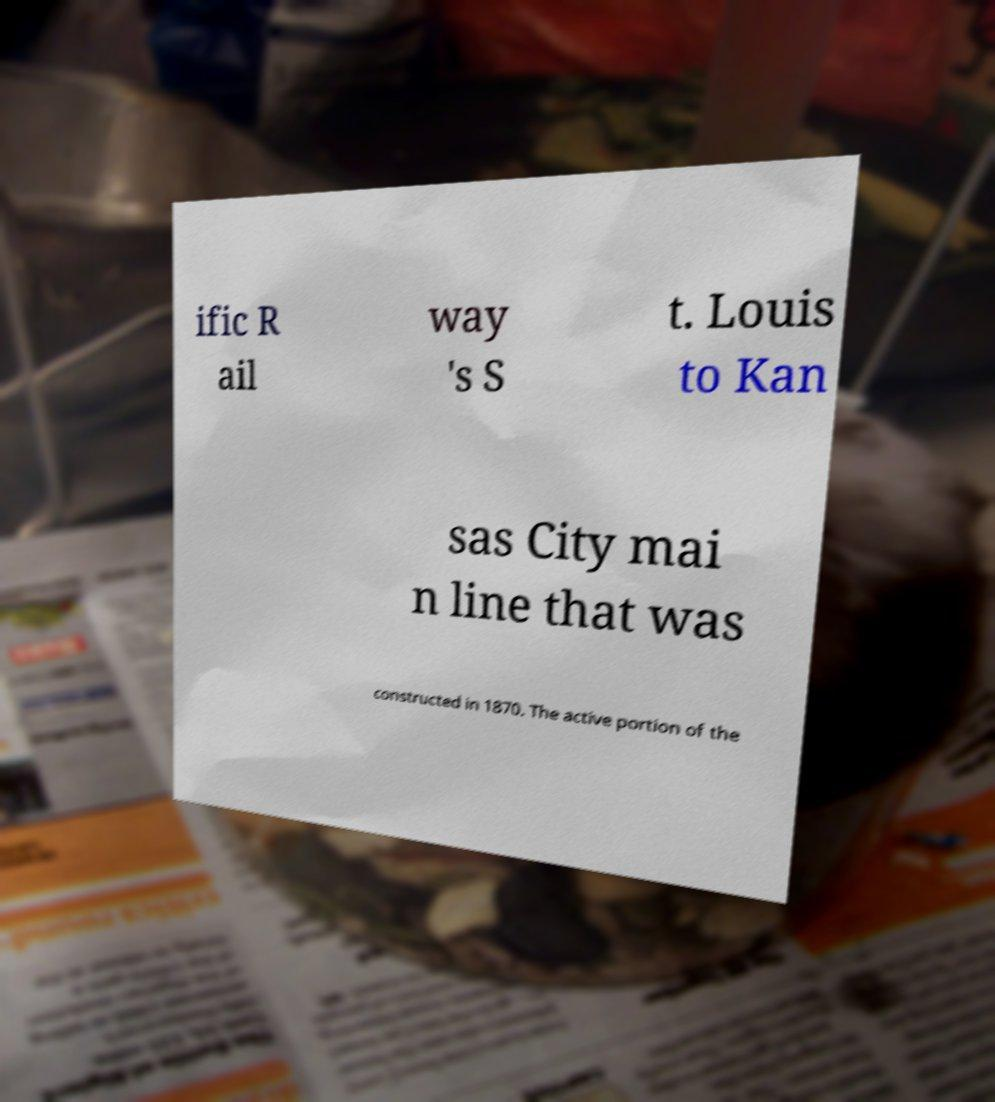Please identify and transcribe the text found in this image. ific R ail way 's S t. Louis to Kan sas City mai n line that was constructed in 1870. The active portion of the 